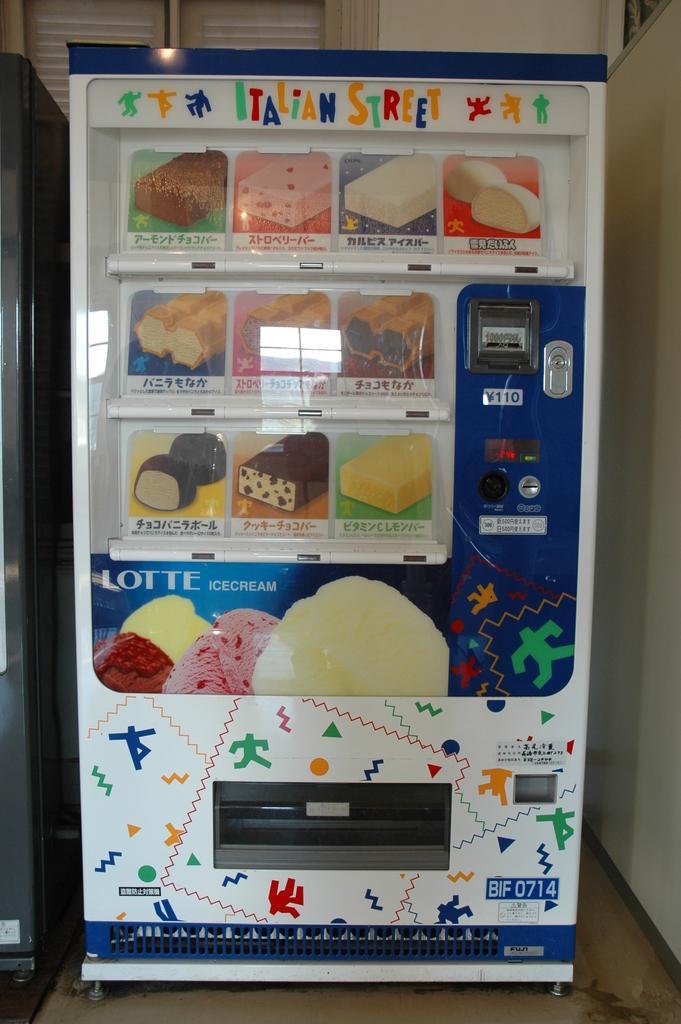Could you give a brief overview of what you see in this image? This a picture highlighted with a vendiman machine. Here we can see different flavours of icecreams, Lotte ice cream. Here we can see different flavors of ice cream scoops. On the background we can see a wall painted with white paint colour. This is a floor. 